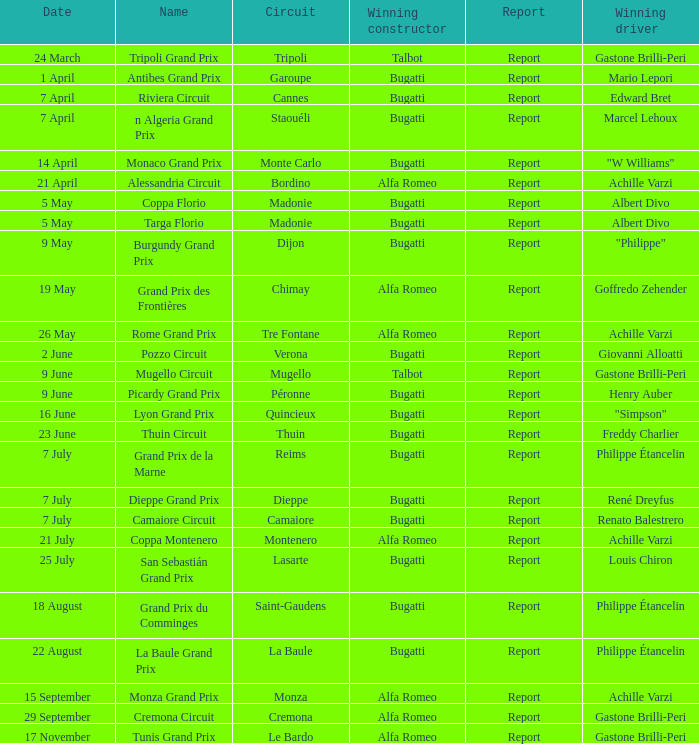What Circuit has a Date of 25 july? Lasarte. 